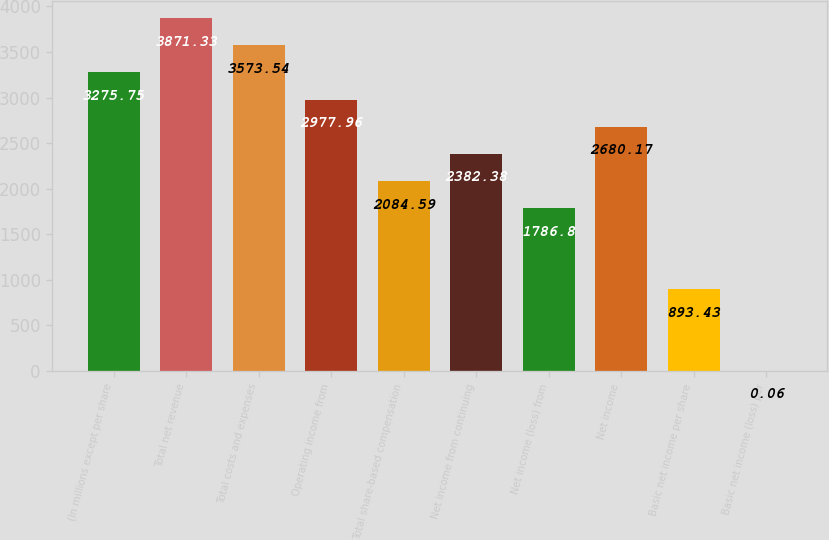<chart> <loc_0><loc_0><loc_500><loc_500><bar_chart><fcel>(In millions except per share<fcel>Total net revenue<fcel>Total costs and expenses<fcel>Operating income from<fcel>Total share-based compensation<fcel>Net income from continuing<fcel>Net income (loss) from<fcel>Net income<fcel>Basic net income per share<fcel>Basic net income (loss) per<nl><fcel>3275.75<fcel>3871.33<fcel>3573.54<fcel>2977.96<fcel>2084.59<fcel>2382.38<fcel>1786.8<fcel>2680.17<fcel>893.43<fcel>0.06<nl></chart> 